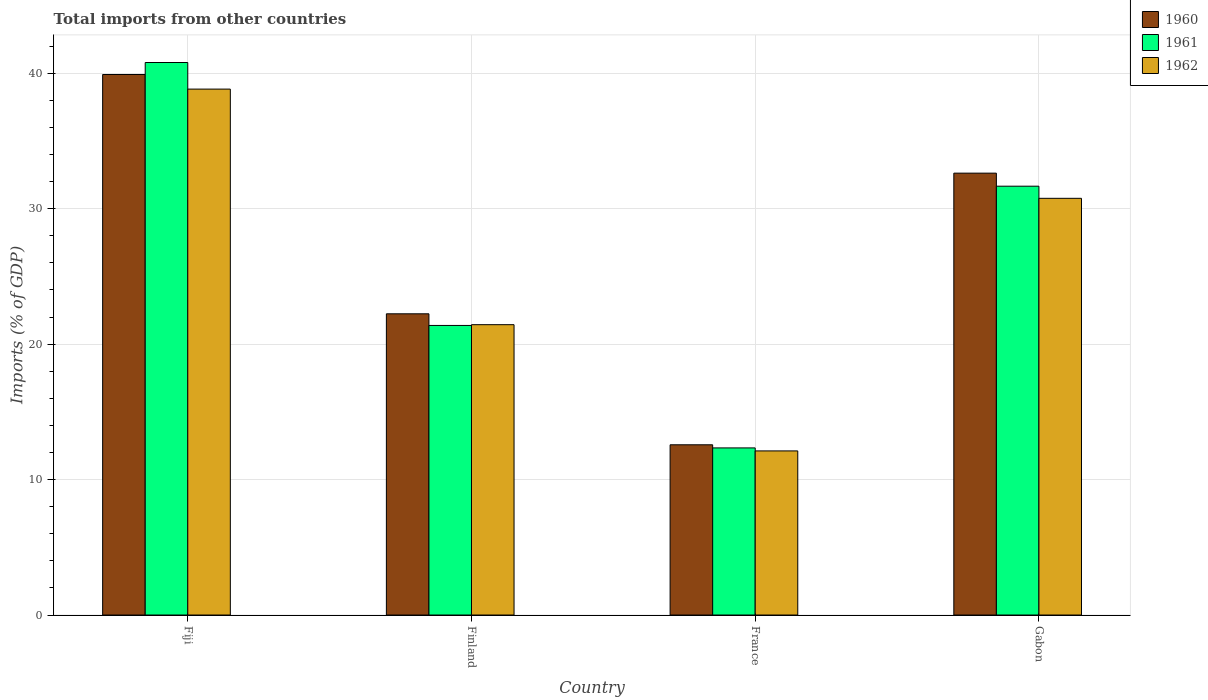How many groups of bars are there?
Offer a very short reply. 4. Are the number of bars per tick equal to the number of legend labels?
Keep it short and to the point. Yes. How many bars are there on the 3rd tick from the left?
Provide a succinct answer. 3. How many bars are there on the 2nd tick from the right?
Ensure brevity in your answer.  3. What is the label of the 4th group of bars from the left?
Provide a succinct answer. Gabon. In how many cases, is the number of bars for a given country not equal to the number of legend labels?
Offer a terse response. 0. What is the total imports in 1961 in Finland?
Offer a very short reply. 21.38. Across all countries, what is the maximum total imports in 1961?
Offer a very short reply. 40.8. Across all countries, what is the minimum total imports in 1961?
Your response must be concise. 12.34. In which country was the total imports in 1960 maximum?
Offer a terse response. Fiji. What is the total total imports in 1961 in the graph?
Keep it short and to the point. 106.18. What is the difference between the total imports in 1961 in Fiji and that in Finland?
Provide a short and direct response. 19.41. What is the difference between the total imports in 1962 in Gabon and the total imports in 1960 in Finland?
Your response must be concise. 8.53. What is the average total imports in 1960 per country?
Your answer should be compact. 26.84. What is the difference between the total imports of/in 1961 and total imports of/in 1960 in France?
Make the answer very short. -0.23. What is the ratio of the total imports in 1962 in Fiji to that in Gabon?
Provide a succinct answer. 1.26. Is the total imports in 1962 in Finland less than that in France?
Keep it short and to the point. No. Is the difference between the total imports in 1961 in Fiji and Finland greater than the difference between the total imports in 1960 in Fiji and Finland?
Ensure brevity in your answer.  Yes. What is the difference between the highest and the second highest total imports in 1962?
Ensure brevity in your answer.  -17.39. What is the difference between the highest and the lowest total imports in 1961?
Make the answer very short. 28.46. In how many countries, is the total imports in 1960 greater than the average total imports in 1960 taken over all countries?
Make the answer very short. 2. Is the sum of the total imports in 1961 in Finland and France greater than the maximum total imports in 1962 across all countries?
Keep it short and to the point. No. What does the 1st bar from the right in France represents?
Ensure brevity in your answer.  1962. Is it the case that in every country, the sum of the total imports in 1961 and total imports in 1962 is greater than the total imports in 1960?
Provide a short and direct response. Yes. Are all the bars in the graph horizontal?
Ensure brevity in your answer.  No. How many countries are there in the graph?
Give a very brief answer. 4. What is the difference between two consecutive major ticks on the Y-axis?
Offer a very short reply. 10. Are the values on the major ticks of Y-axis written in scientific E-notation?
Give a very brief answer. No. Does the graph contain any zero values?
Provide a short and direct response. No. Where does the legend appear in the graph?
Ensure brevity in your answer.  Top right. How many legend labels are there?
Provide a succinct answer. 3. What is the title of the graph?
Give a very brief answer. Total imports from other countries. What is the label or title of the X-axis?
Offer a very short reply. Country. What is the label or title of the Y-axis?
Keep it short and to the point. Imports (% of GDP). What is the Imports (% of GDP) in 1960 in Fiji?
Give a very brief answer. 39.91. What is the Imports (% of GDP) in 1961 in Fiji?
Your answer should be very brief. 40.8. What is the Imports (% of GDP) of 1962 in Fiji?
Your answer should be compact. 38.83. What is the Imports (% of GDP) in 1960 in Finland?
Your response must be concise. 22.24. What is the Imports (% of GDP) of 1961 in Finland?
Give a very brief answer. 21.38. What is the Imports (% of GDP) of 1962 in Finland?
Make the answer very short. 21.44. What is the Imports (% of GDP) of 1960 in France?
Ensure brevity in your answer.  12.57. What is the Imports (% of GDP) of 1961 in France?
Provide a succinct answer. 12.34. What is the Imports (% of GDP) of 1962 in France?
Keep it short and to the point. 12.12. What is the Imports (% of GDP) of 1960 in Gabon?
Ensure brevity in your answer.  32.63. What is the Imports (% of GDP) in 1961 in Gabon?
Provide a succinct answer. 31.66. What is the Imports (% of GDP) of 1962 in Gabon?
Make the answer very short. 30.77. Across all countries, what is the maximum Imports (% of GDP) in 1960?
Your answer should be very brief. 39.91. Across all countries, what is the maximum Imports (% of GDP) in 1961?
Offer a terse response. 40.8. Across all countries, what is the maximum Imports (% of GDP) in 1962?
Provide a short and direct response. 38.83. Across all countries, what is the minimum Imports (% of GDP) of 1960?
Your answer should be very brief. 12.57. Across all countries, what is the minimum Imports (% of GDP) of 1961?
Your answer should be very brief. 12.34. Across all countries, what is the minimum Imports (% of GDP) in 1962?
Your answer should be very brief. 12.12. What is the total Imports (% of GDP) of 1960 in the graph?
Your answer should be very brief. 107.35. What is the total Imports (% of GDP) in 1961 in the graph?
Give a very brief answer. 106.18. What is the total Imports (% of GDP) of 1962 in the graph?
Make the answer very short. 103.16. What is the difference between the Imports (% of GDP) in 1960 in Fiji and that in Finland?
Make the answer very short. 17.67. What is the difference between the Imports (% of GDP) of 1961 in Fiji and that in Finland?
Make the answer very short. 19.41. What is the difference between the Imports (% of GDP) in 1962 in Fiji and that in Finland?
Your answer should be very brief. 17.39. What is the difference between the Imports (% of GDP) of 1960 in Fiji and that in France?
Make the answer very short. 27.34. What is the difference between the Imports (% of GDP) of 1961 in Fiji and that in France?
Keep it short and to the point. 28.46. What is the difference between the Imports (% of GDP) in 1962 in Fiji and that in France?
Ensure brevity in your answer.  26.72. What is the difference between the Imports (% of GDP) in 1960 in Fiji and that in Gabon?
Provide a succinct answer. 7.28. What is the difference between the Imports (% of GDP) in 1961 in Fiji and that in Gabon?
Offer a terse response. 9.13. What is the difference between the Imports (% of GDP) in 1962 in Fiji and that in Gabon?
Ensure brevity in your answer.  8.06. What is the difference between the Imports (% of GDP) of 1960 in Finland and that in France?
Offer a very short reply. 9.67. What is the difference between the Imports (% of GDP) in 1961 in Finland and that in France?
Give a very brief answer. 9.04. What is the difference between the Imports (% of GDP) in 1962 in Finland and that in France?
Provide a succinct answer. 9.32. What is the difference between the Imports (% of GDP) in 1960 in Finland and that in Gabon?
Provide a short and direct response. -10.39. What is the difference between the Imports (% of GDP) in 1961 in Finland and that in Gabon?
Keep it short and to the point. -10.28. What is the difference between the Imports (% of GDP) of 1962 in Finland and that in Gabon?
Offer a very short reply. -9.33. What is the difference between the Imports (% of GDP) in 1960 in France and that in Gabon?
Provide a succinct answer. -20.06. What is the difference between the Imports (% of GDP) in 1961 in France and that in Gabon?
Provide a succinct answer. -19.32. What is the difference between the Imports (% of GDP) of 1962 in France and that in Gabon?
Offer a very short reply. -18.65. What is the difference between the Imports (% of GDP) of 1960 in Fiji and the Imports (% of GDP) of 1961 in Finland?
Your response must be concise. 18.53. What is the difference between the Imports (% of GDP) in 1960 in Fiji and the Imports (% of GDP) in 1962 in Finland?
Make the answer very short. 18.47. What is the difference between the Imports (% of GDP) in 1961 in Fiji and the Imports (% of GDP) in 1962 in Finland?
Offer a very short reply. 19.36. What is the difference between the Imports (% of GDP) of 1960 in Fiji and the Imports (% of GDP) of 1961 in France?
Your answer should be very brief. 27.57. What is the difference between the Imports (% of GDP) in 1960 in Fiji and the Imports (% of GDP) in 1962 in France?
Keep it short and to the point. 27.79. What is the difference between the Imports (% of GDP) in 1961 in Fiji and the Imports (% of GDP) in 1962 in France?
Keep it short and to the point. 28.68. What is the difference between the Imports (% of GDP) in 1960 in Fiji and the Imports (% of GDP) in 1961 in Gabon?
Provide a succinct answer. 8.25. What is the difference between the Imports (% of GDP) in 1960 in Fiji and the Imports (% of GDP) in 1962 in Gabon?
Give a very brief answer. 9.14. What is the difference between the Imports (% of GDP) of 1961 in Fiji and the Imports (% of GDP) of 1962 in Gabon?
Your response must be concise. 10.03. What is the difference between the Imports (% of GDP) in 1960 in Finland and the Imports (% of GDP) in 1961 in France?
Make the answer very short. 9.9. What is the difference between the Imports (% of GDP) in 1960 in Finland and the Imports (% of GDP) in 1962 in France?
Offer a very short reply. 10.12. What is the difference between the Imports (% of GDP) of 1961 in Finland and the Imports (% of GDP) of 1962 in France?
Your response must be concise. 9.26. What is the difference between the Imports (% of GDP) in 1960 in Finland and the Imports (% of GDP) in 1961 in Gabon?
Offer a very short reply. -9.42. What is the difference between the Imports (% of GDP) of 1960 in Finland and the Imports (% of GDP) of 1962 in Gabon?
Keep it short and to the point. -8.53. What is the difference between the Imports (% of GDP) of 1961 in Finland and the Imports (% of GDP) of 1962 in Gabon?
Your answer should be very brief. -9.39. What is the difference between the Imports (% of GDP) in 1960 in France and the Imports (% of GDP) in 1961 in Gabon?
Your response must be concise. -19.09. What is the difference between the Imports (% of GDP) of 1960 in France and the Imports (% of GDP) of 1962 in Gabon?
Provide a succinct answer. -18.2. What is the difference between the Imports (% of GDP) of 1961 in France and the Imports (% of GDP) of 1962 in Gabon?
Your answer should be compact. -18.43. What is the average Imports (% of GDP) in 1960 per country?
Provide a succinct answer. 26.84. What is the average Imports (% of GDP) in 1961 per country?
Keep it short and to the point. 26.55. What is the average Imports (% of GDP) in 1962 per country?
Your answer should be compact. 25.79. What is the difference between the Imports (% of GDP) of 1960 and Imports (% of GDP) of 1961 in Fiji?
Your answer should be compact. -0.89. What is the difference between the Imports (% of GDP) of 1960 and Imports (% of GDP) of 1962 in Fiji?
Your answer should be very brief. 1.08. What is the difference between the Imports (% of GDP) of 1961 and Imports (% of GDP) of 1962 in Fiji?
Offer a very short reply. 1.96. What is the difference between the Imports (% of GDP) of 1960 and Imports (% of GDP) of 1961 in Finland?
Provide a succinct answer. 0.86. What is the difference between the Imports (% of GDP) in 1960 and Imports (% of GDP) in 1962 in Finland?
Your response must be concise. 0.8. What is the difference between the Imports (% of GDP) of 1961 and Imports (% of GDP) of 1962 in Finland?
Your answer should be very brief. -0.06. What is the difference between the Imports (% of GDP) of 1960 and Imports (% of GDP) of 1961 in France?
Ensure brevity in your answer.  0.23. What is the difference between the Imports (% of GDP) in 1960 and Imports (% of GDP) in 1962 in France?
Make the answer very short. 0.45. What is the difference between the Imports (% of GDP) of 1961 and Imports (% of GDP) of 1962 in France?
Your response must be concise. 0.22. What is the difference between the Imports (% of GDP) in 1960 and Imports (% of GDP) in 1961 in Gabon?
Offer a terse response. 0.96. What is the difference between the Imports (% of GDP) of 1960 and Imports (% of GDP) of 1962 in Gabon?
Your answer should be very brief. 1.86. What is the difference between the Imports (% of GDP) in 1961 and Imports (% of GDP) in 1962 in Gabon?
Provide a succinct answer. 0.89. What is the ratio of the Imports (% of GDP) in 1960 in Fiji to that in Finland?
Provide a short and direct response. 1.79. What is the ratio of the Imports (% of GDP) in 1961 in Fiji to that in Finland?
Keep it short and to the point. 1.91. What is the ratio of the Imports (% of GDP) in 1962 in Fiji to that in Finland?
Ensure brevity in your answer.  1.81. What is the ratio of the Imports (% of GDP) in 1960 in Fiji to that in France?
Make the answer very short. 3.18. What is the ratio of the Imports (% of GDP) in 1961 in Fiji to that in France?
Make the answer very short. 3.31. What is the ratio of the Imports (% of GDP) in 1962 in Fiji to that in France?
Provide a succinct answer. 3.2. What is the ratio of the Imports (% of GDP) of 1960 in Fiji to that in Gabon?
Offer a terse response. 1.22. What is the ratio of the Imports (% of GDP) of 1961 in Fiji to that in Gabon?
Make the answer very short. 1.29. What is the ratio of the Imports (% of GDP) of 1962 in Fiji to that in Gabon?
Make the answer very short. 1.26. What is the ratio of the Imports (% of GDP) of 1960 in Finland to that in France?
Your answer should be very brief. 1.77. What is the ratio of the Imports (% of GDP) of 1961 in Finland to that in France?
Offer a very short reply. 1.73. What is the ratio of the Imports (% of GDP) of 1962 in Finland to that in France?
Your response must be concise. 1.77. What is the ratio of the Imports (% of GDP) in 1960 in Finland to that in Gabon?
Keep it short and to the point. 0.68. What is the ratio of the Imports (% of GDP) of 1961 in Finland to that in Gabon?
Ensure brevity in your answer.  0.68. What is the ratio of the Imports (% of GDP) in 1962 in Finland to that in Gabon?
Offer a very short reply. 0.7. What is the ratio of the Imports (% of GDP) of 1960 in France to that in Gabon?
Give a very brief answer. 0.39. What is the ratio of the Imports (% of GDP) of 1961 in France to that in Gabon?
Offer a terse response. 0.39. What is the ratio of the Imports (% of GDP) of 1962 in France to that in Gabon?
Provide a short and direct response. 0.39. What is the difference between the highest and the second highest Imports (% of GDP) in 1960?
Make the answer very short. 7.28. What is the difference between the highest and the second highest Imports (% of GDP) in 1961?
Make the answer very short. 9.13. What is the difference between the highest and the second highest Imports (% of GDP) of 1962?
Make the answer very short. 8.06. What is the difference between the highest and the lowest Imports (% of GDP) in 1960?
Your answer should be very brief. 27.34. What is the difference between the highest and the lowest Imports (% of GDP) in 1961?
Your response must be concise. 28.46. What is the difference between the highest and the lowest Imports (% of GDP) of 1962?
Offer a very short reply. 26.72. 